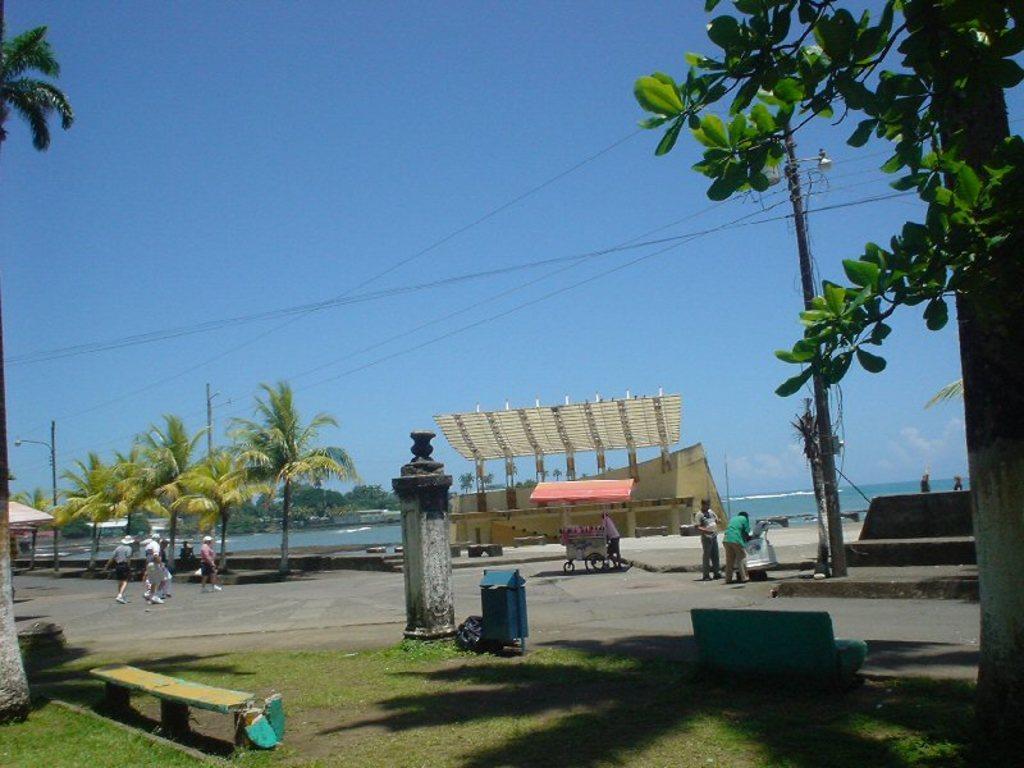How would you summarize this image in a sentence or two? In this image I can see group of people some are standing and some are walking. Background I see an electric pole, trees in green color, water and sky in blue color. 